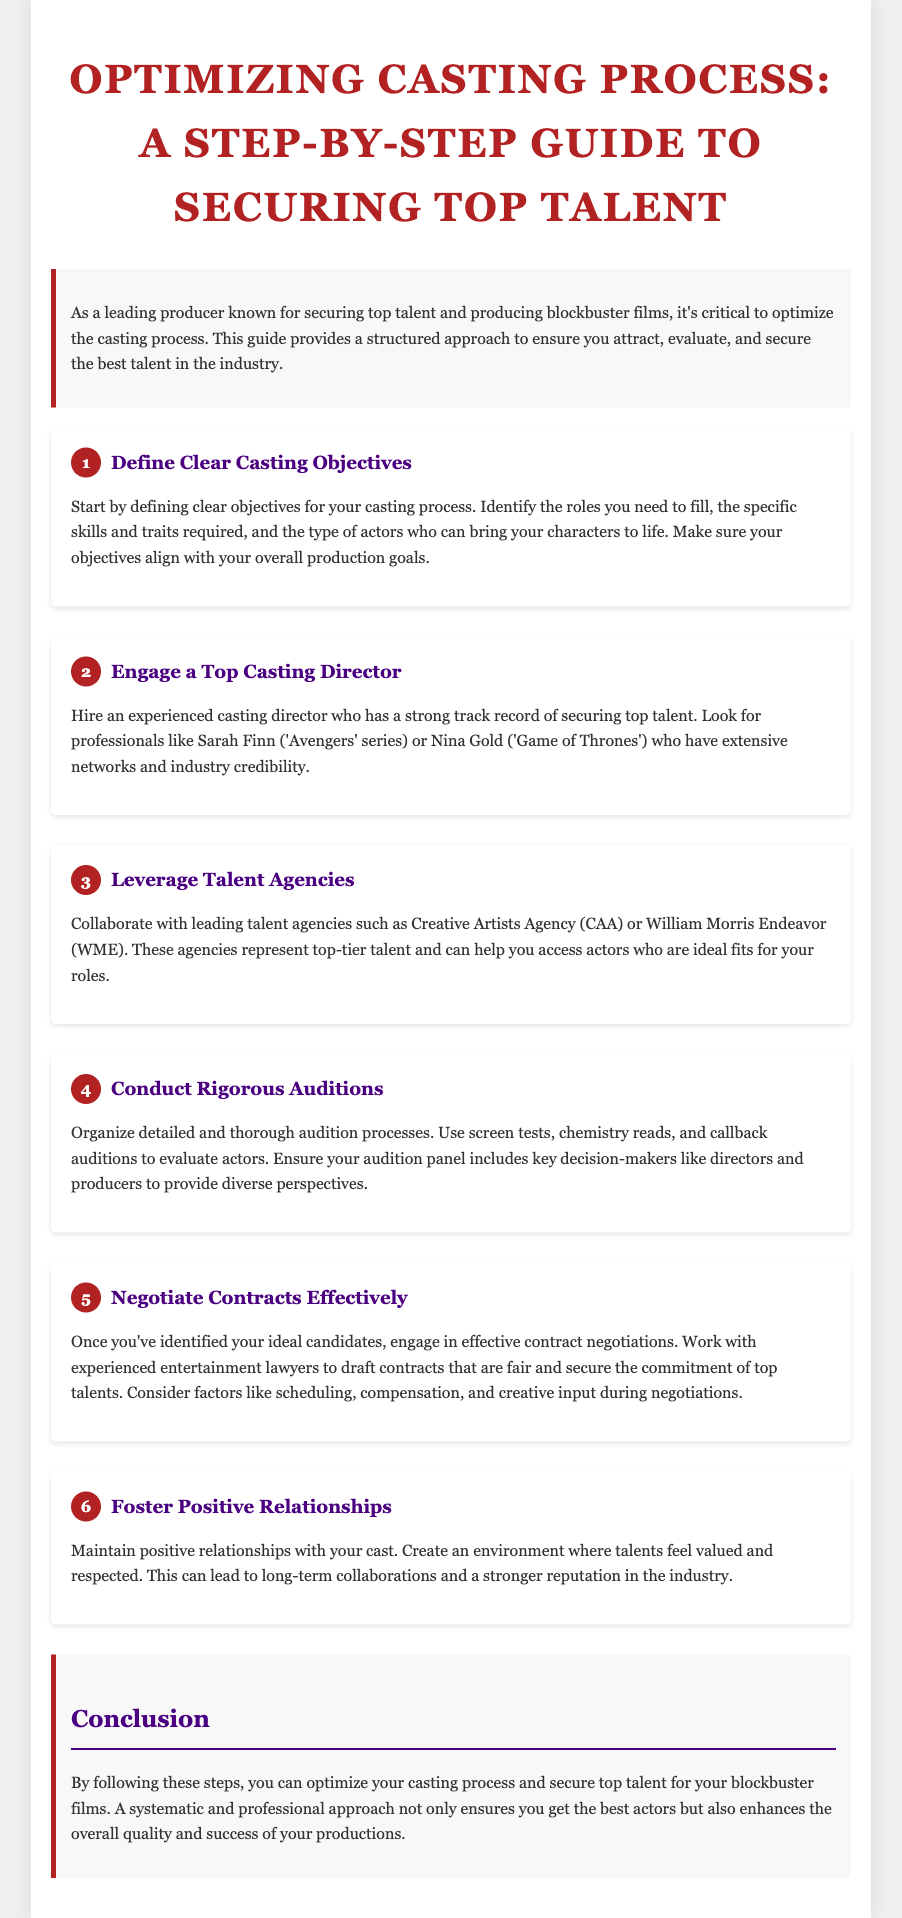what is the title of the guide? The title of the guide is provided at the beginning of the document.
Answer: Optimizing Casting Process: A Step-by-Step Guide to Securing Top Talent who is suggested as a casting director in the guide? The guide mentions specific casting directors as examples of experts in the field.
Answer: Sarah Finn how many steps are outlined in the casting process? The document clearly lists the steps in the casting process numerically.
Answer: 6 what is the first step in optimizing the casting process? The steps are enumerated in order, starting from step one.
Answer: Define Clear Casting Objectives which talent agencies are recommended for collaboration? The guide lists specific talent agencies that can assist in the casting process.
Answer: Creative Artists Agency (CAA) what should be included in the audition panel according to the guide? The document specifies who should be part of the audition panel to ensure effective evaluations.
Answer: Key decision-makers why is fostering positive relationships with the cast important? The guide explains the benefits of maintaining strong relationships within the industry.
Answer: Leads to long-term collaborations what role do entertainment lawyers play in the casting process? The guide describes the involvement of professionals in the contractual aspect of casting.
Answer: Negotiate contracts what is the concluding message of the guide? The conclusion summarizes the overall importance of the outlined steps in the casting process.
Answer: Optimize your casting process and secure top talent 